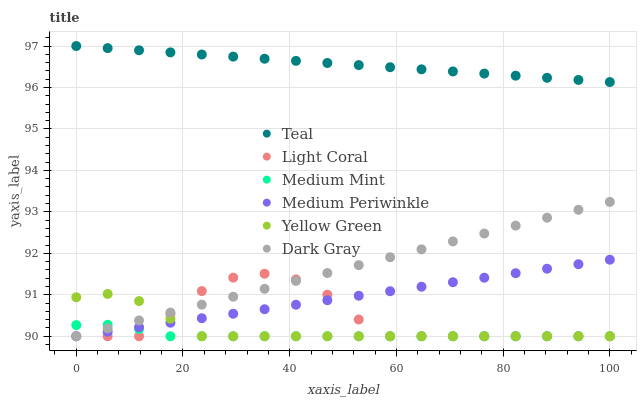Does Medium Mint have the minimum area under the curve?
Answer yes or no. Yes. Does Teal have the maximum area under the curve?
Answer yes or no. Yes. Does Dark Gray have the minimum area under the curve?
Answer yes or no. No. Does Dark Gray have the maximum area under the curve?
Answer yes or no. No. Is Teal the smoothest?
Answer yes or no. Yes. Is Light Coral the roughest?
Answer yes or no. Yes. Is Dark Gray the smoothest?
Answer yes or no. No. Is Dark Gray the roughest?
Answer yes or no. No. Does Medium Mint have the lowest value?
Answer yes or no. Yes. Does Teal have the lowest value?
Answer yes or no. No. Does Teal have the highest value?
Answer yes or no. Yes. Does Dark Gray have the highest value?
Answer yes or no. No. Is Medium Mint less than Teal?
Answer yes or no. Yes. Is Teal greater than Medium Mint?
Answer yes or no. Yes. Does Yellow Green intersect Light Coral?
Answer yes or no. Yes. Is Yellow Green less than Light Coral?
Answer yes or no. No. Is Yellow Green greater than Light Coral?
Answer yes or no. No. Does Medium Mint intersect Teal?
Answer yes or no. No. 